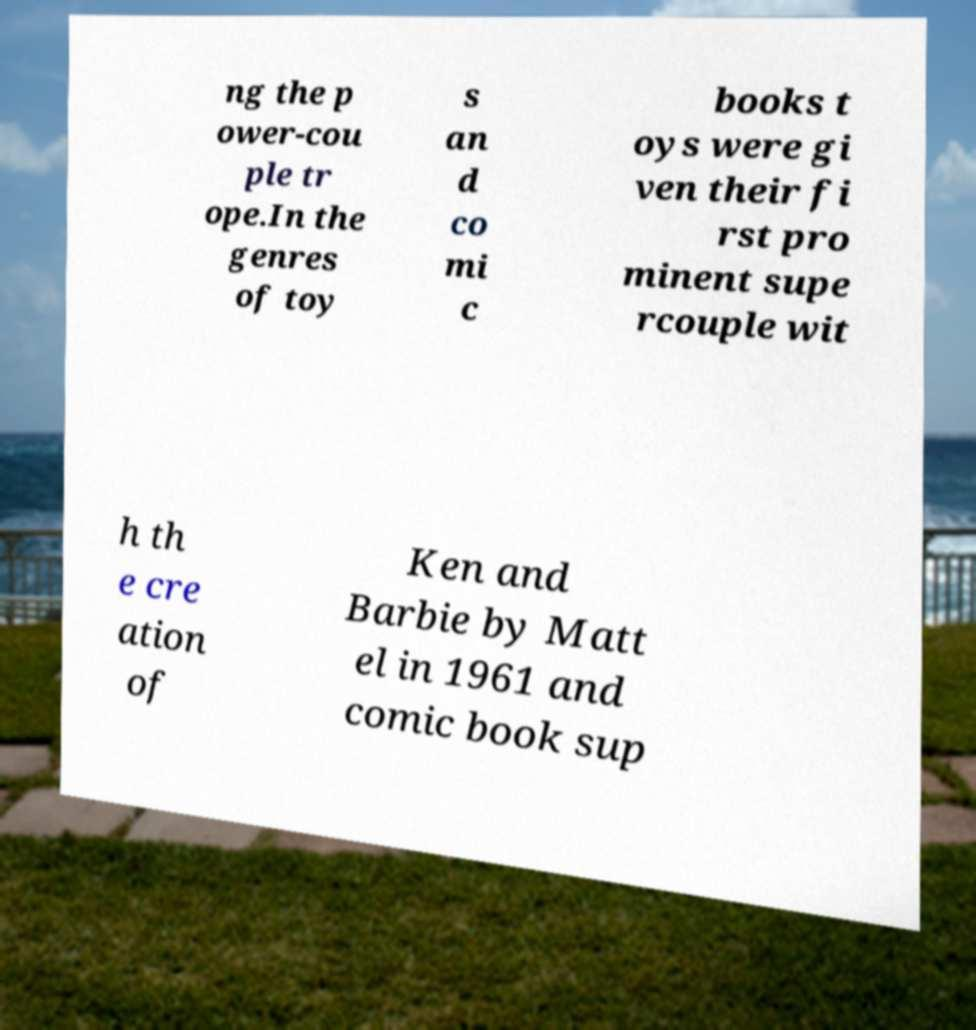Please read and relay the text visible in this image. What does it say? ng the p ower-cou ple tr ope.In the genres of toy s an d co mi c books t oys were gi ven their fi rst pro minent supe rcouple wit h th e cre ation of Ken and Barbie by Matt el in 1961 and comic book sup 